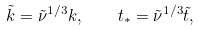Convert formula to latex. <formula><loc_0><loc_0><loc_500><loc_500>\tilde { k } = \tilde { \nu } ^ { 1 / 3 } k , \quad t _ { * } = \tilde { \nu } ^ { 1 / 3 } \tilde { t } ,</formula> 